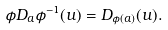<formula> <loc_0><loc_0><loc_500><loc_500>\phi D _ { a } \phi ^ { - 1 } ( u ) = D _ { \phi ( a ) } ( u ) .</formula> 